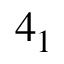Convert formula to latex. <formula><loc_0><loc_0><loc_500><loc_500>4 _ { 1 }</formula> 